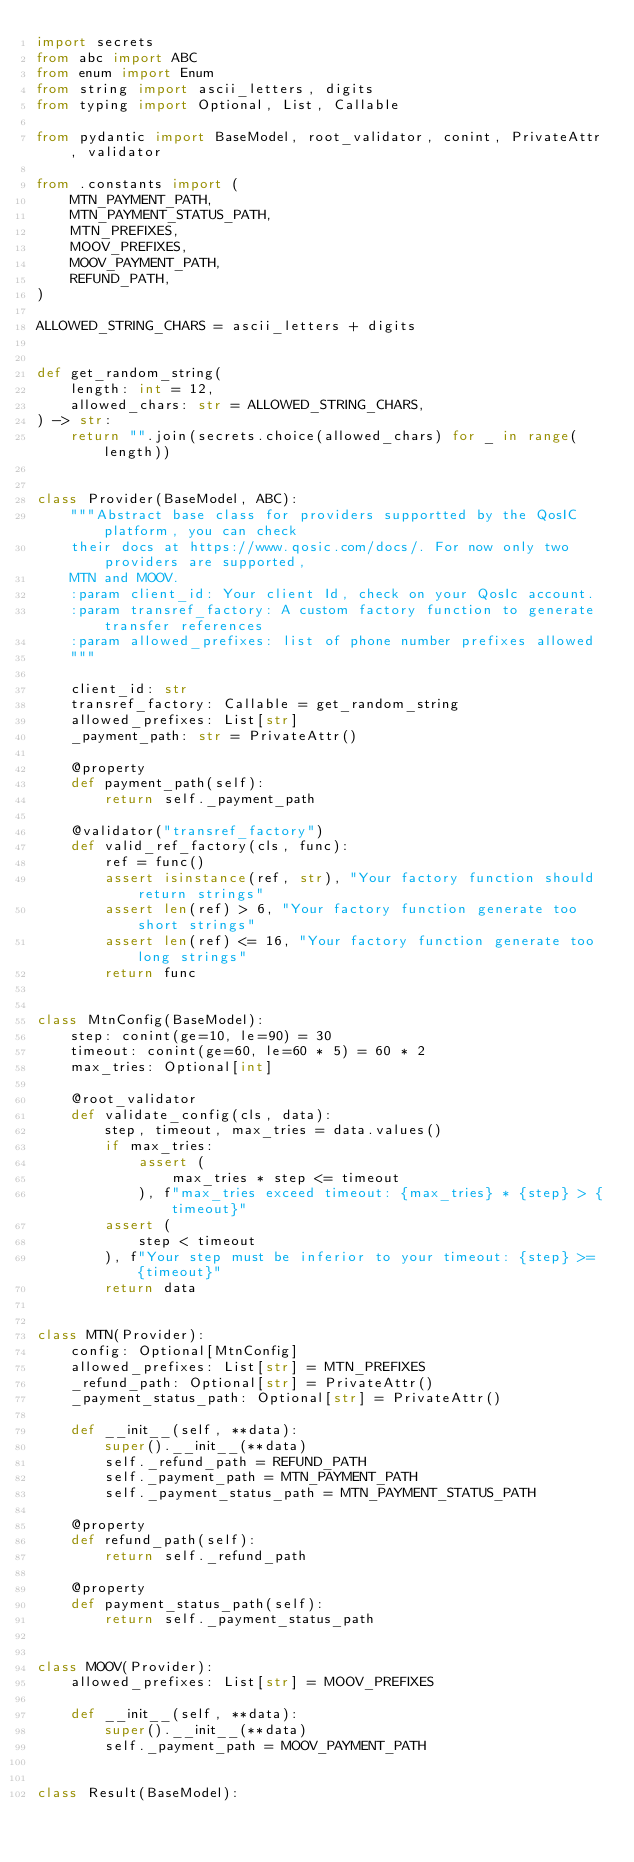<code> <loc_0><loc_0><loc_500><loc_500><_Python_>import secrets
from abc import ABC
from enum import Enum
from string import ascii_letters, digits
from typing import Optional, List, Callable

from pydantic import BaseModel, root_validator, conint, PrivateAttr, validator

from .constants import (
    MTN_PAYMENT_PATH,
    MTN_PAYMENT_STATUS_PATH,
    MTN_PREFIXES,
    MOOV_PREFIXES,
    MOOV_PAYMENT_PATH,
    REFUND_PATH,
)

ALLOWED_STRING_CHARS = ascii_letters + digits


def get_random_string(
    length: int = 12,
    allowed_chars: str = ALLOWED_STRING_CHARS,
) -> str:
    return "".join(secrets.choice(allowed_chars) for _ in range(length))


class Provider(BaseModel, ABC):
    """Abstract base class for providers supportted by the QosIC platform, you can check
    their docs at https://www.qosic.com/docs/. For now only two providers are supported,
    MTN and MOOV.
    :param client_id: Your client Id, check on your QosIc account.
    :param transref_factory: A custom factory function to generate transfer references
    :param allowed_prefixes: list of phone number prefixes allowed
    """

    client_id: str
    transref_factory: Callable = get_random_string
    allowed_prefixes: List[str]
    _payment_path: str = PrivateAttr()

    @property
    def payment_path(self):
        return self._payment_path

    @validator("transref_factory")
    def valid_ref_factory(cls, func):
        ref = func()
        assert isinstance(ref, str), "Your factory function should return strings"
        assert len(ref) > 6, "Your factory function generate too short strings"
        assert len(ref) <= 16, "Your factory function generate too long strings"
        return func


class MtnConfig(BaseModel):
    step: conint(ge=10, le=90) = 30
    timeout: conint(ge=60, le=60 * 5) = 60 * 2
    max_tries: Optional[int]

    @root_validator
    def validate_config(cls, data):
        step, timeout, max_tries = data.values()
        if max_tries:
            assert (
                max_tries * step <= timeout
            ), f"max_tries exceed timeout: {max_tries} * {step} > {timeout}"
        assert (
            step < timeout
        ), f"Your step must be inferior to your timeout: {step} >= {timeout}"
        return data


class MTN(Provider):
    config: Optional[MtnConfig]
    allowed_prefixes: List[str] = MTN_PREFIXES
    _refund_path: Optional[str] = PrivateAttr()
    _payment_status_path: Optional[str] = PrivateAttr()

    def __init__(self, **data):
        super().__init__(**data)
        self._refund_path = REFUND_PATH
        self._payment_path = MTN_PAYMENT_PATH
        self._payment_status_path = MTN_PAYMENT_STATUS_PATH

    @property
    def refund_path(self):
        return self._refund_path

    @property
    def payment_status_path(self):
        return self._payment_status_path


class MOOV(Provider):
    allowed_prefixes: List[str] = MOOV_PREFIXES

    def __init__(self, **data):
        super().__init__(**data)
        self._payment_path = MOOV_PAYMENT_PATH


class Result(BaseModel):</code> 